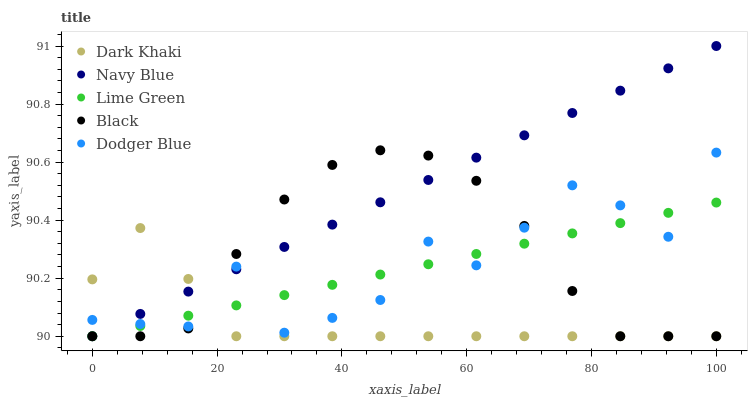Does Dark Khaki have the minimum area under the curve?
Answer yes or no. Yes. Does Navy Blue have the maximum area under the curve?
Answer yes or no. Yes. Does Lime Green have the minimum area under the curve?
Answer yes or no. No. Does Lime Green have the maximum area under the curve?
Answer yes or no. No. Is Lime Green the smoothest?
Answer yes or no. Yes. Is Dodger Blue the roughest?
Answer yes or no. Yes. Is Navy Blue the smoothest?
Answer yes or no. No. Is Navy Blue the roughest?
Answer yes or no. No. Does Dark Khaki have the lowest value?
Answer yes or no. Yes. Does Dodger Blue have the lowest value?
Answer yes or no. No. Does Navy Blue have the highest value?
Answer yes or no. Yes. Does Lime Green have the highest value?
Answer yes or no. No. Does Navy Blue intersect Black?
Answer yes or no. Yes. Is Navy Blue less than Black?
Answer yes or no. No. Is Navy Blue greater than Black?
Answer yes or no. No. 